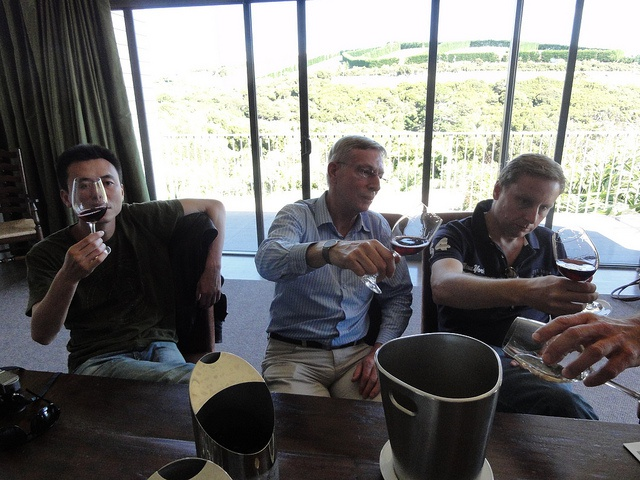Describe the objects in this image and their specific colors. I can see dining table in black, gray, tan, and darkgray tones, people in black, gray, maroon, and darkgray tones, people in black and gray tones, people in black, gray, and darkgray tones, and bowl in black, gray, and darkgray tones in this image. 